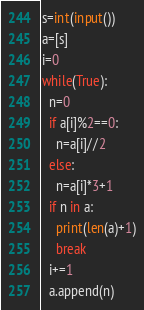Convert code to text. <code><loc_0><loc_0><loc_500><loc_500><_Python_>s=int(input())
a=[s]
i=0
while(True):
  n=0
  if a[i]%2==0:
    n=a[i]//2
  else:
    n=a[i]*3+1
  if n in a:
    print(len(a)+1)
    break
  i+=1
  a.append(n)
</code> 